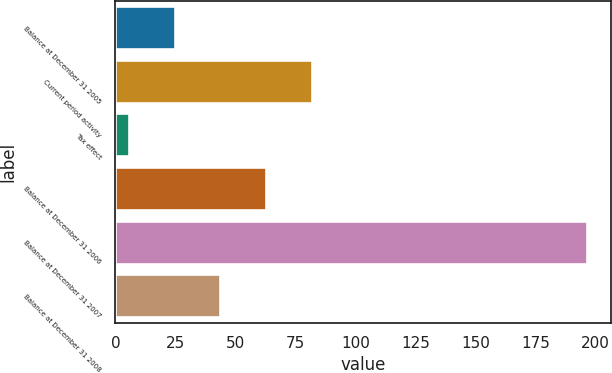<chart> <loc_0><loc_0><loc_500><loc_500><bar_chart><fcel>Balance at December 31 2005<fcel>Current period activity<fcel>Tax effect<fcel>Balance at December 31 2006<fcel>Balance at December 31 2007<fcel>Balance at December 31 2008<nl><fcel>24.7<fcel>82<fcel>5.6<fcel>62.9<fcel>196.6<fcel>43.8<nl></chart> 